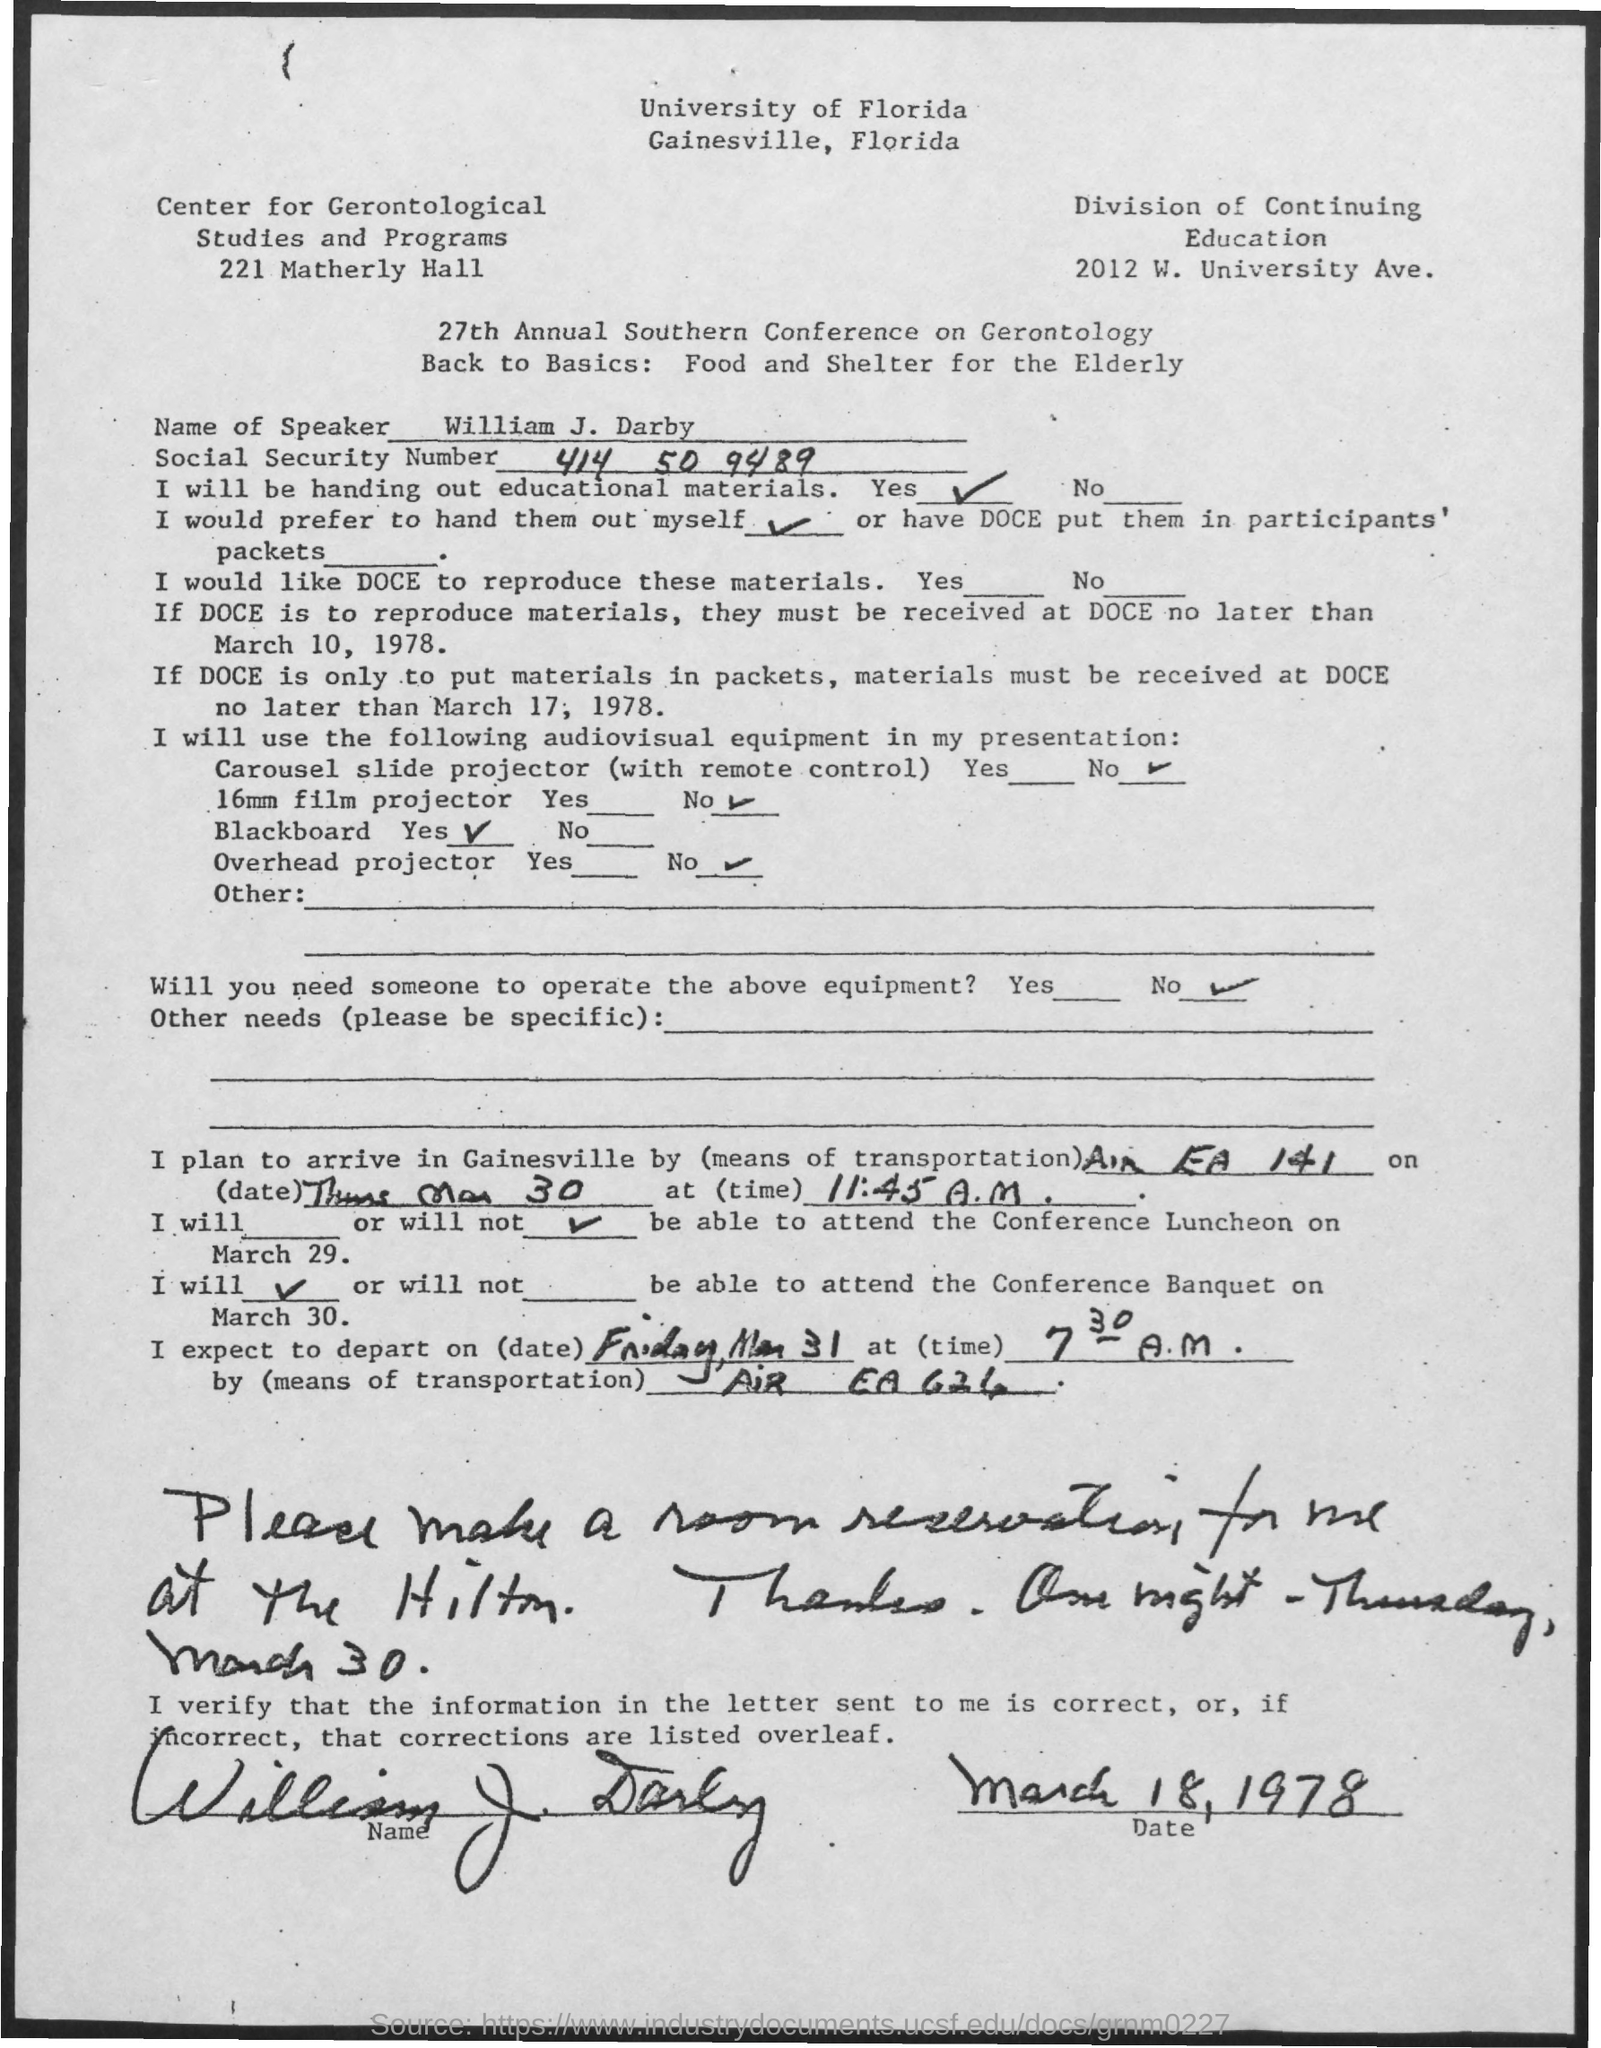List a handful of essential elements in this visual. The Social Security Number is a unique nine-digit number assigned to individuals for the purpose of tracking their earnings and determining their eligibility for various government programs and benefits, such as retirement, disability, and health insurance. The first three digits of the Social Security Number represent the state in which the individual was issued the number, the next two digits represent the office that issued the number, and the final four digits represent the individual's unique number within that state. The Social Security Number is not intended to be used for identification purposes outside of government programs and benefits. 